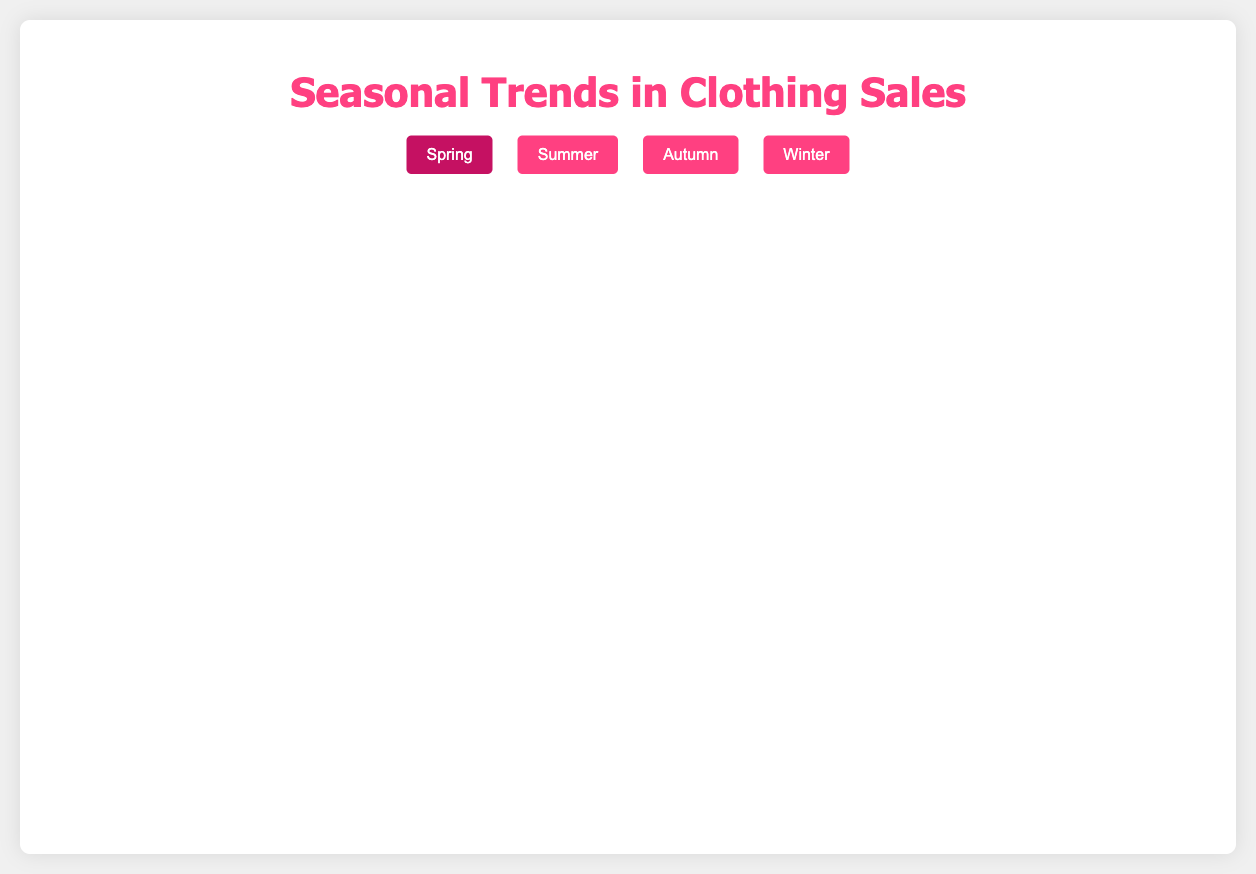What is the highest sales figure for H&M in Winter over the past five years? The highest sales figure for H&M in Winter can be seen in the year 2022 with a value of 1950 on the Y-axis corresponding to the year 2022 on the X-axis.
Answer: 1950 Which brand had the lowest sales in Spring 2021? In Spring 2021, the points corresponding to each brand show that Zara had the lowest sales with the value at 1300 on the Y-axis.
Answer: Zara What is the total sales for Topshop in Summer across all five years combined? Adding the sales for the years 2018 (1800), 2019 (1900), 2020 (2000), 2021 (2200), and 2022 (2100), we get 1800 + 1900 + 2000 + 2200 + 2100 = 10,000.
Answer: 10,000 Which season showed the most significant sales increase for Zara from 2020 to 2021? Comparing the points for Zara from 2020 to 2021, Summer shows sales increasing from 1950 to 2100, a +150 change, which is the most significant.
Answer: Summer How do the sales trends for H&M compare to Zara in Autumn over the past five years? Both brands show an increasing trend, but H&M consistently sells higher. In 2018, H&M starts at 1550, steadily rises to 1850 in 2022, whereas Zara starts at 1450 and ends at 1800.
Answer: H&M has higher sales Which brand experienced the most sales volatility in Winter over the past five years? Topshop shows fluctuations with values 1700, 1800, 1900, 1850, and 2000, compared to more stable trends in H&M and Zara.
Answer: Topshop What was the average Spring sales for Zara over the past five years? Sum Zara's Spring sales: 1350 + 1580 + 1450 + 1300 + 1650 = 7330; Divide by 5 (number of years): 7330 / 5 = 1466.
Answer: 1466 In Summer 2020, which brand had the highest sales increase compared to the previous year? Comparing Summer sales of 2020 with 2019, H&M increased from 1850 to 2100 by 250, the largest increase among the brands.
Answer: H&M Close Examination: How does the fluctuation in Autumn sales for Topshop compare with H&M's fluctuation over the past five years? Topshop fluctuates moderately with 1600, 1700, 1800, 1750, and 1900. H&M starts at 1550 then moves steadily up to 1850. Both have upward trends but Topshop shows slight dips.
Answer: Similar fluctuations What is the difference in Winter sales between H&M and Zara in 2022? The sales for H&M in Winter 2022 is 1950 and for Zara is 1900. The difference: 1950 - 1900 = 50.
Answer: 50 